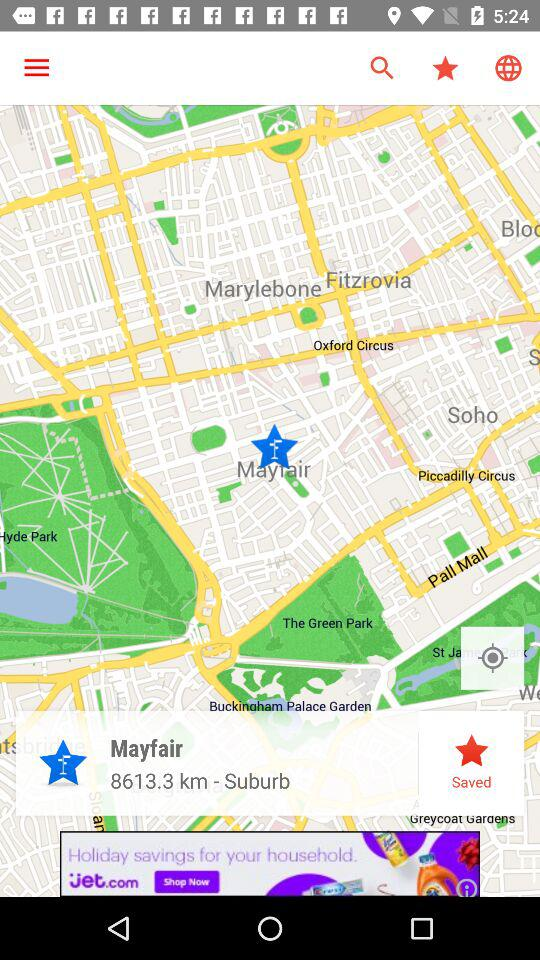What is the distance of Mayfair? The distance of Mayfair is 8613.3 km. 